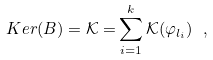<formula> <loc_0><loc_0><loc_500><loc_500>K e r ( B ) = \mathcal { K = } \sum _ { i = 1 } ^ { k } \mathcal { K ( } \varphi _ { l _ { i } } ) \ ,</formula> 